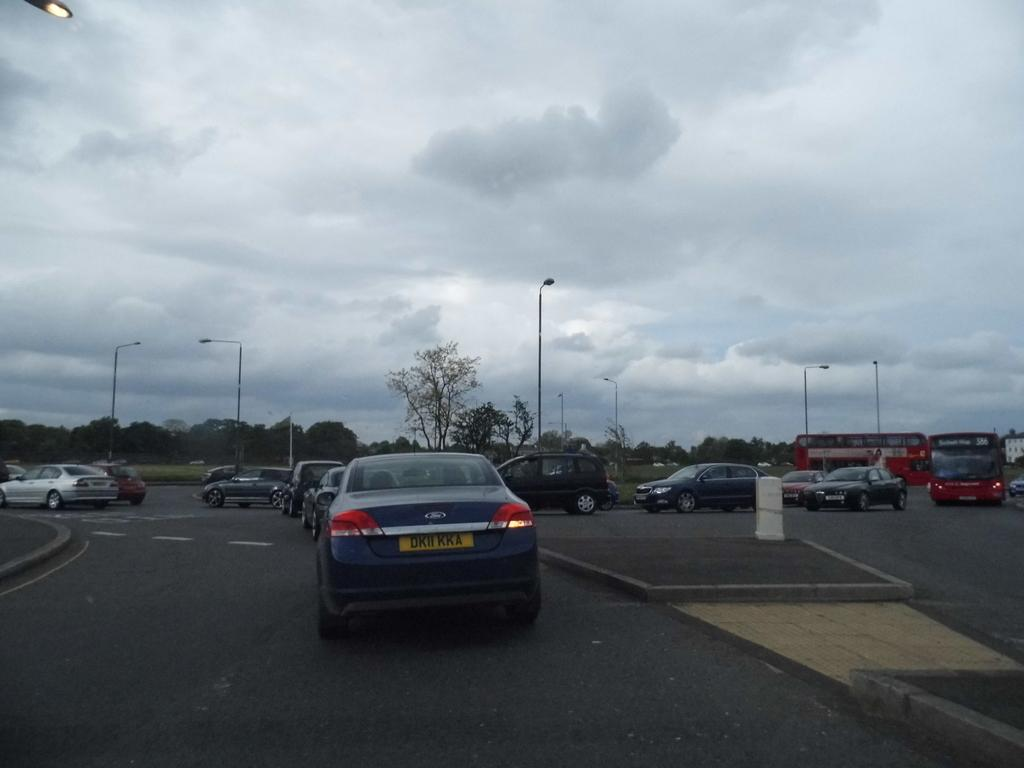What can be seen on the road in the image? There are vehicles on the road in the image. What objects are present in the image besides the vehicles? There are poles, lights, trees, and a building in the image. What is visible in the background of the image? The sky is visible in the background of the image. How does love manifest itself in the image? There is no indication of love in the image, as it primarily features vehicles, poles, lights, trees, a building, and the sky. What type of window can be seen in the image? There is no window present in the image. 